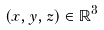<formula> <loc_0><loc_0><loc_500><loc_500>( x , y , z ) \in \mathbb { R } ^ { 3 }</formula> 